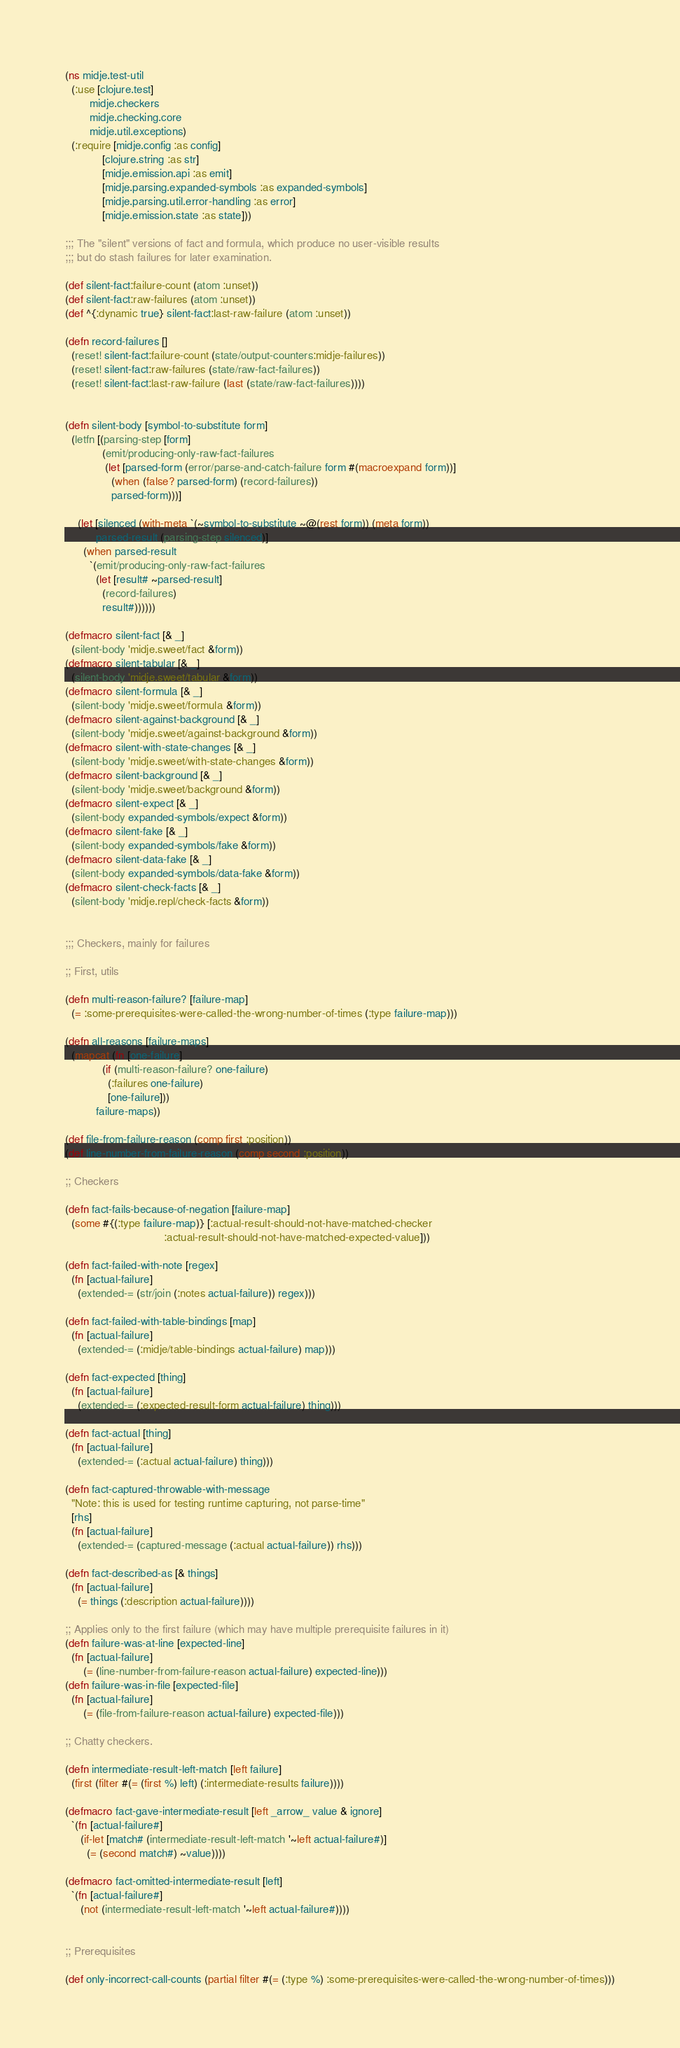<code> <loc_0><loc_0><loc_500><loc_500><_Clojure_>(ns midje.test-util
  (:use [clojure.test]
        midje.checkers
        midje.checking.core
        midje.util.exceptions)
  (:require [midje.config :as config]
            [clojure.string :as str]
            [midje.emission.api :as emit]
            [midje.parsing.expanded-symbols :as expanded-symbols]
            [midje.parsing.util.error-handling :as error]
            [midje.emission.state :as state]))

;;; The "silent" versions of fact and formula, which produce no user-visible results
;;; but do stash failures for later examination.

(def silent-fact:failure-count (atom :unset))
(def silent-fact:raw-failures (atom :unset))
(def ^{:dynamic true} silent-fact:last-raw-failure (atom :unset))

(defn record-failures []
  (reset! silent-fact:failure-count (state/output-counters:midje-failures))
  (reset! silent-fact:raw-failures (state/raw-fact-failures))
  (reset! silent-fact:last-raw-failure (last (state/raw-fact-failures))))


(defn silent-body [symbol-to-substitute form]
  (letfn [(parsing-step [form]
            (emit/producing-only-raw-fact-failures
             (let [parsed-form (error/parse-and-catch-failure form #(macroexpand form))]
               (when (false? parsed-form) (record-failures))
               parsed-form)))]

    (let [silenced (with-meta `(~symbol-to-substitute ~@(rest form)) (meta form))
          parsed-result (parsing-step silenced)]
      (when parsed-result
        `(emit/producing-only-raw-fact-failures
          (let [result# ~parsed-result]
            (record-failures)
            result#))))))

(defmacro silent-fact [& _]
  (silent-body 'midje.sweet/fact &form))
(defmacro silent-tabular [& _]
  (silent-body 'midje.sweet/tabular &form))
(defmacro silent-formula [& _]
  (silent-body 'midje.sweet/formula &form))
(defmacro silent-against-background [& _]
  (silent-body 'midje.sweet/against-background &form))
(defmacro silent-with-state-changes [& _]
  (silent-body 'midje.sweet/with-state-changes &form))
(defmacro silent-background [& _]
  (silent-body 'midje.sweet/background &form))
(defmacro silent-expect [& _]
  (silent-body expanded-symbols/expect &form))
(defmacro silent-fake [& _]
  (silent-body expanded-symbols/fake &form))
(defmacro silent-data-fake [& _]
  (silent-body expanded-symbols/data-fake &form))
(defmacro silent-check-facts [& _]
  (silent-body 'midje.repl/check-facts &form))
  

;;; Checkers, mainly for failures

;; First, utils

(defn multi-reason-failure? [failure-map]
  (= :some-prerequisites-were-called-the-wrong-number-of-times (:type failure-map)))

(defn all-reasons [failure-maps]
  (mapcat (fn [one-failure]
            (if (multi-reason-failure? one-failure)
              (:failures one-failure)
              [one-failure]))
          failure-maps))

(def file-from-failure-reason (comp first :position))
(def line-number-from-failure-reason (comp second :position))

;; Checkers

(defn fact-fails-because-of-negation [failure-map]
  (some #{(:type failure-map)} [:actual-result-should-not-have-matched-checker
                                :actual-result-should-not-have-matched-expected-value]))

(defn fact-failed-with-note [regex]
  (fn [actual-failure]
    (extended-= (str/join (:notes actual-failure)) regex)))

(defn fact-failed-with-table-bindings [map]
  (fn [actual-failure]
    (extended-= (:midje/table-bindings actual-failure) map)))

(defn fact-expected [thing]
  (fn [actual-failure]
    (extended-= (:expected-result-form actual-failure) thing)))

(defn fact-actual [thing]
  (fn [actual-failure]
    (extended-= (:actual actual-failure) thing)))

(defn fact-captured-throwable-with-message
  "Note: this is used for testing runtime capturing, not parse-time"
  [rhs]
  (fn [actual-failure]
    (extended-= (captured-message (:actual actual-failure)) rhs)))

(defn fact-described-as [& things]
  (fn [actual-failure]
    (= things (:description actual-failure))))

;; Applies only to the first failure (which may have multiple prerequisite failures in it)
(defn failure-was-at-line [expected-line]
  (fn [actual-failure]
      (= (line-number-from-failure-reason actual-failure) expected-line)))
(defn failure-was-in-file [expected-file]
  (fn [actual-failure]
      (= (file-from-failure-reason actual-failure) expected-file)))

;; Chatty checkers.

(defn intermediate-result-left-match [left failure]
  (first (filter #(= (first %) left) (:intermediate-results failure))))

(defmacro fact-gave-intermediate-result [left _arrow_ value & ignore]
  `(fn [actual-failure#]
     (if-let [match# (intermediate-result-left-match '~left actual-failure#)]
       (= (second match#) ~value))))
      
(defmacro fact-omitted-intermediate-result [left]
  `(fn [actual-failure#]
     (not (intermediate-result-left-match '~left actual-failure#))))
  

;; Prerequisites

(def only-incorrect-call-counts (partial filter #(= (:type %) :some-prerequisites-were-called-the-wrong-number-of-times)))</code> 